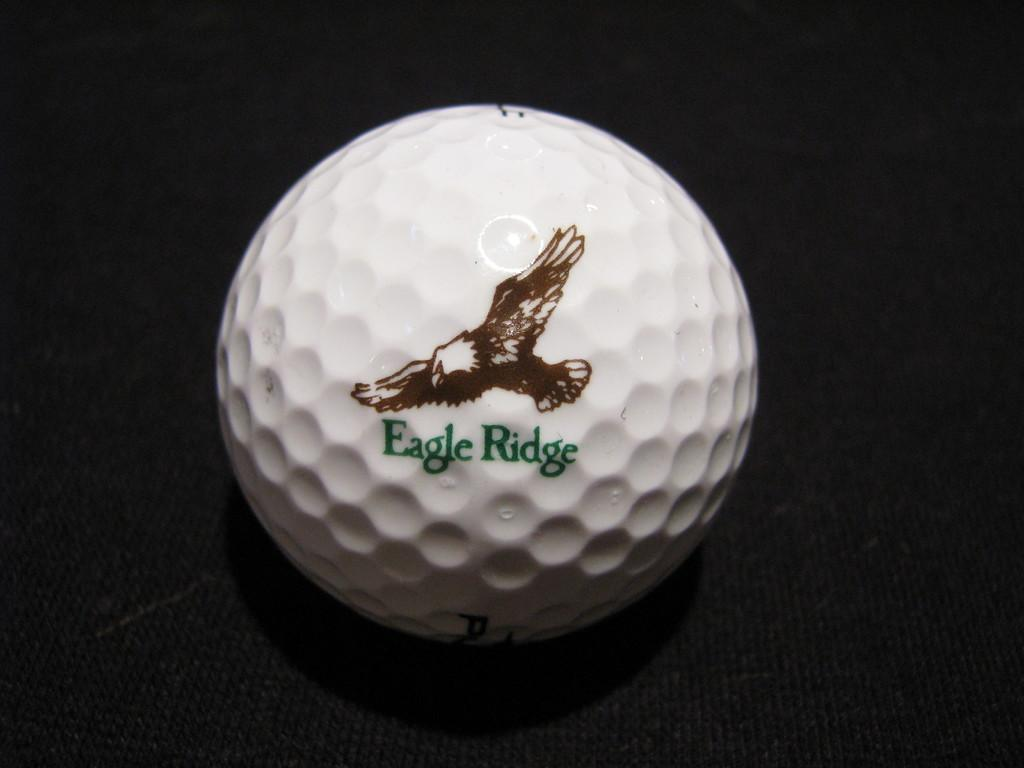What object is the main focus of the image? There is a ball in the image. What is the ball placed on? The ball is on a black color platform. What is depicted on the ball? There is a picture of a bird on the ball. Are there any words or letters on the ball? Yes, there is text written on the ball. What type of spring can be seen attached to the bird on the ball? There is no spring present in the image; it only features a ball with a picture of a bird and text. Can you recite the verse written on the ball? There is no verse present on the ball; it only has text, which cannot be recited without knowing its content. 